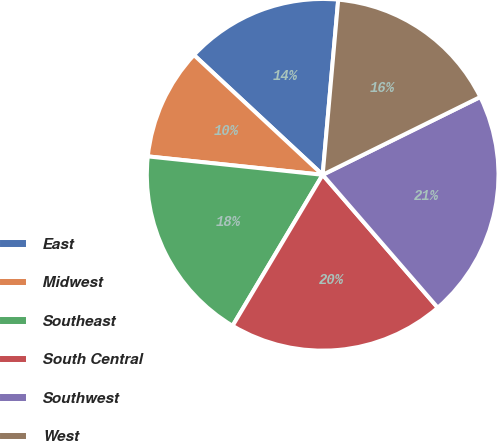Convert chart to OTSL. <chart><loc_0><loc_0><loc_500><loc_500><pie_chart><fcel>East<fcel>Midwest<fcel>Southeast<fcel>South Central<fcel>Southwest<fcel>West<nl><fcel>14.48%<fcel>10.26%<fcel>18.11%<fcel>19.92%<fcel>20.94%<fcel>16.29%<nl></chart> 